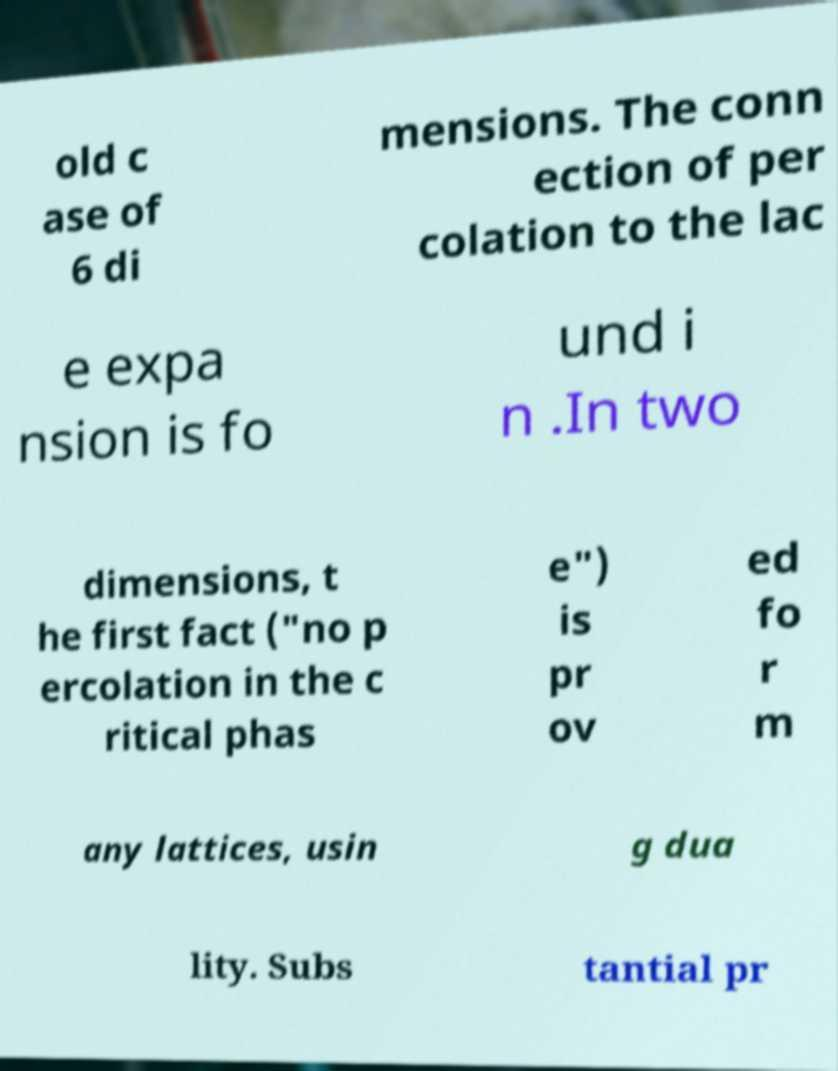Can you read and provide the text displayed in the image?This photo seems to have some interesting text. Can you extract and type it out for me? old c ase of 6 di mensions. The conn ection of per colation to the lac e expa nsion is fo und i n .In two dimensions, t he first fact ("no p ercolation in the c ritical phas e") is pr ov ed fo r m any lattices, usin g dua lity. Subs tantial pr 